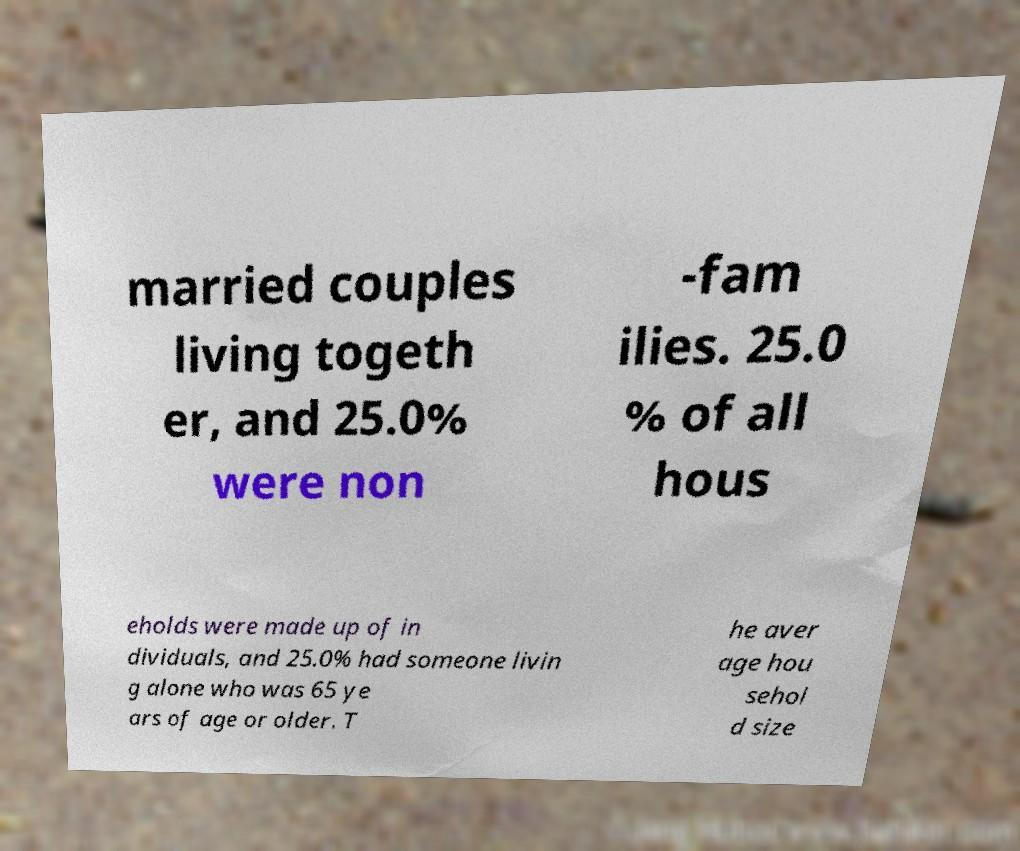Could you assist in decoding the text presented in this image and type it out clearly? married couples living togeth er, and 25.0% were non -fam ilies. 25.0 % of all hous eholds were made up of in dividuals, and 25.0% had someone livin g alone who was 65 ye ars of age or older. T he aver age hou sehol d size 